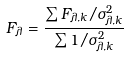<formula> <loc_0><loc_0><loc_500><loc_500>F _ { \lambda } = \frac { \sum F _ { \lambda , k } / \sigma ^ { 2 } _ { \lambda , k } } { \sum 1 / \sigma ^ { 2 } _ { \lambda , k } }</formula> 